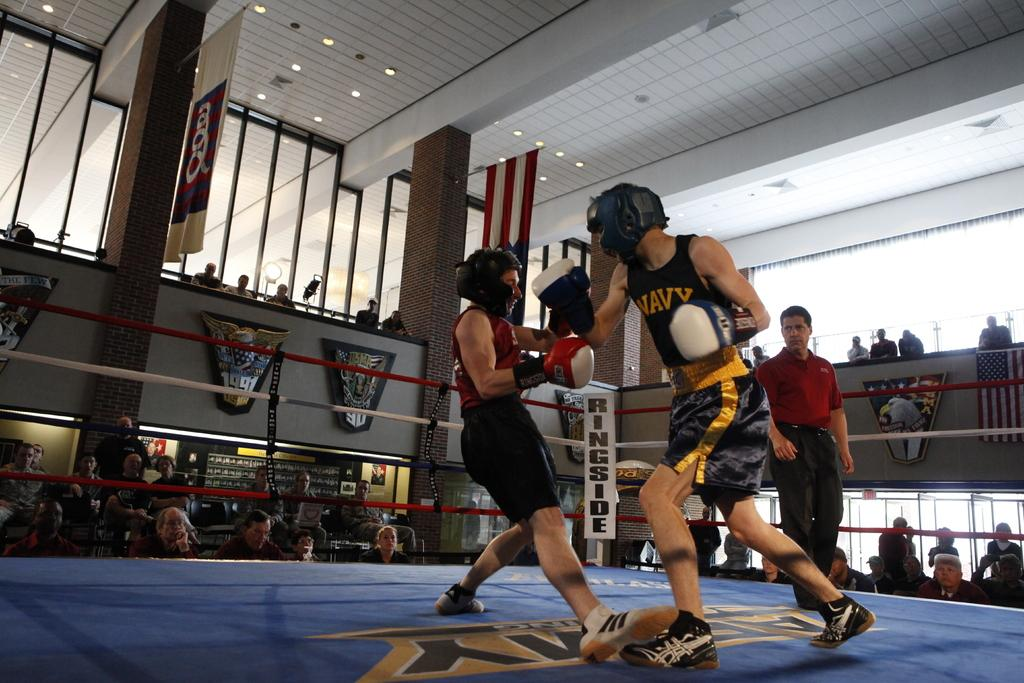<image>
Render a clear and concise summary of the photo. A man in a navy tank top is in a boxing match. 